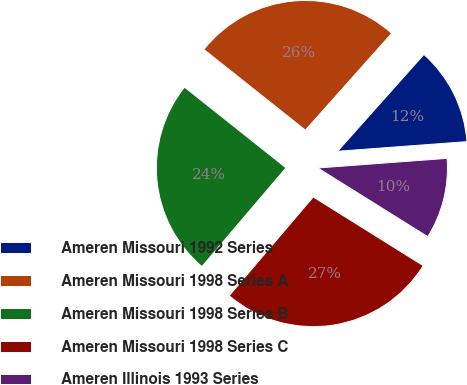Convert chart. <chart><loc_0><loc_0><loc_500><loc_500><pie_chart><fcel>Ameren Missouri 1992 Series<fcel>Ameren Missouri 1998 Series A<fcel>Ameren Missouri 1998 Series B<fcel>Ameren Missouri 1998 Series C<fcel>Ameren Illinois 1993 Series<nl><fcel>12.23%<fcel>25.9%<fcel>24.46%<fcel>27.34%<fcel>10.07%<nl></chart> 